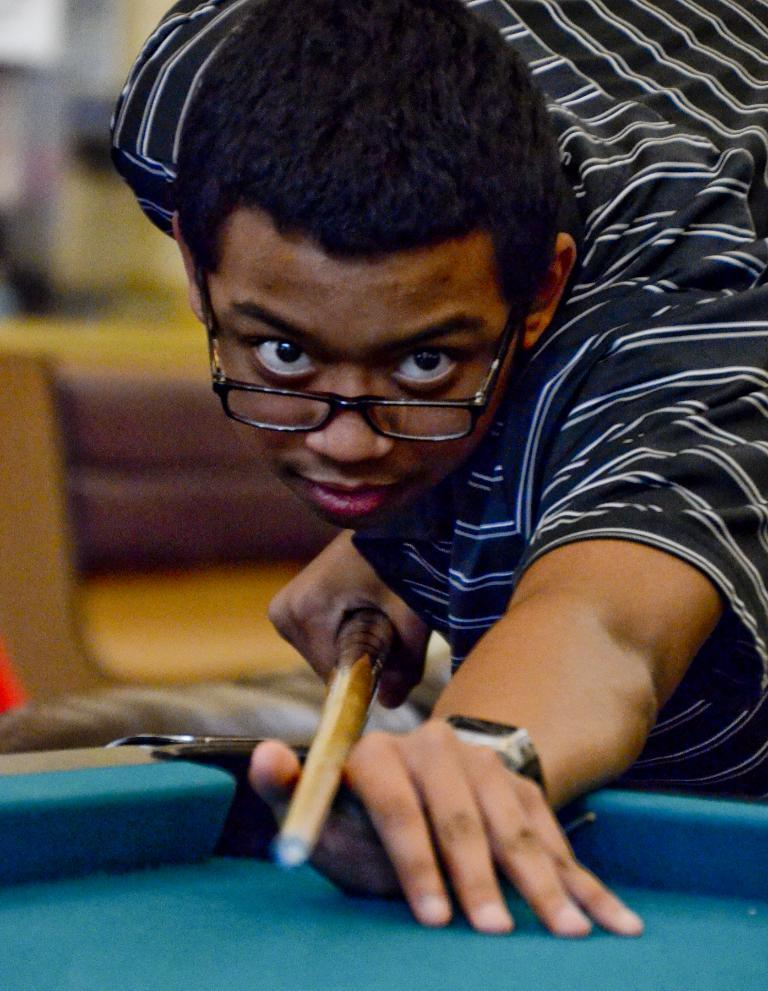What is the main subject of the image? The main subject of the image is a man. What is the man doing in the image? The man is playing a snooker game in the image. What type of sock is the monkey wearing while eating pies in the image? There is no monkey or sock present in the image, nor are there any pies being eaten. 